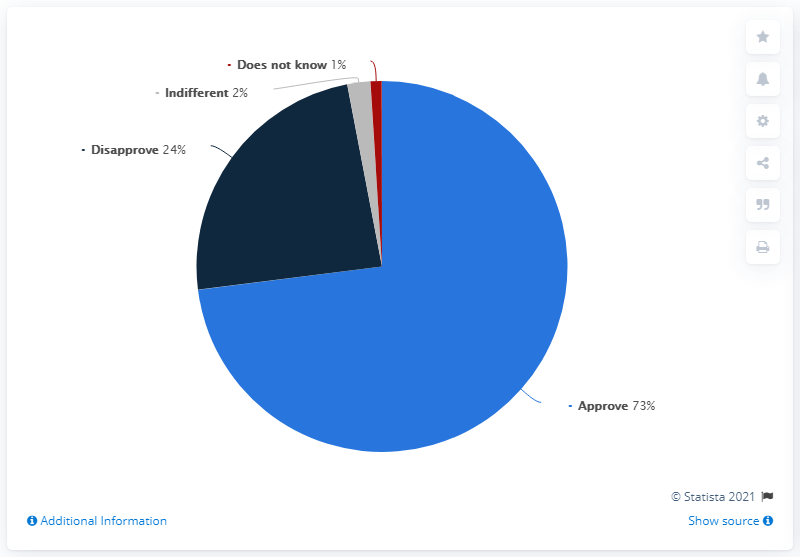Specify some key components in this picture. The sum other than approve is 27. Seventy-three people approve. 